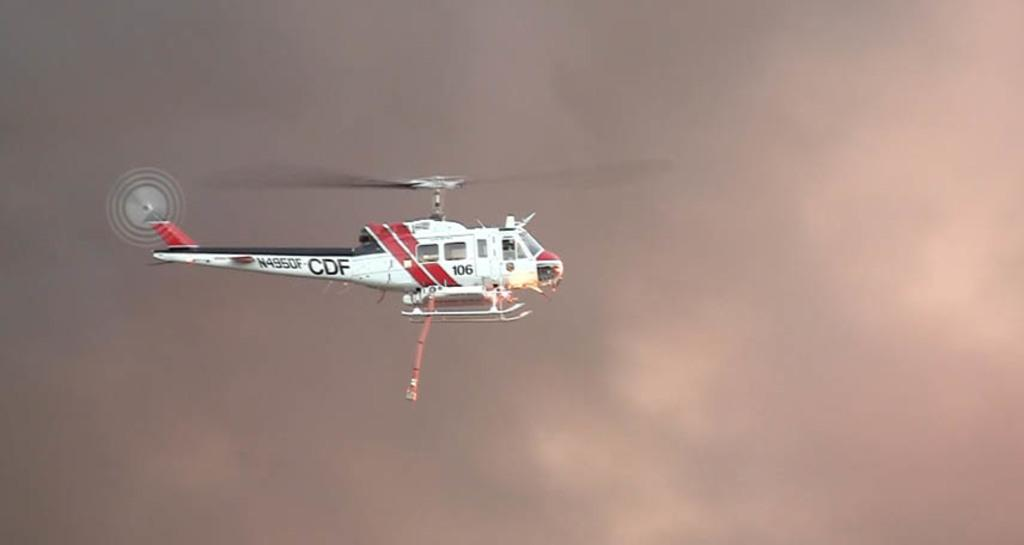What is the main subject of the image? The main subject of the image is a helicopter. What is the helicopter doing in the image? The helicopter is flying in the air. What can be seen in the background of the image? There are clouds visible in the background of the image. What type of story is being told by the gold nest in the image? There is no gold nest present in the image, so no story can be told by it. 